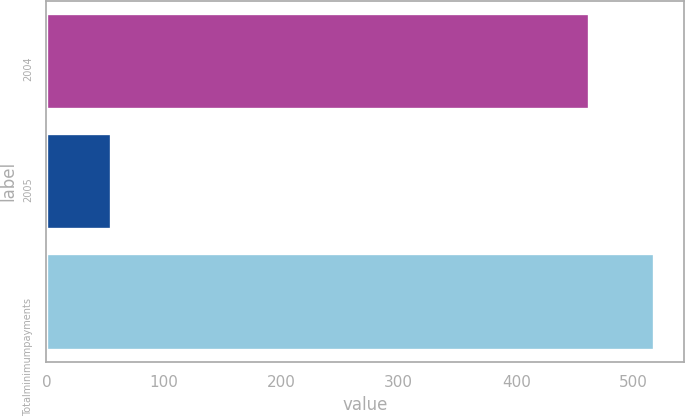Convert chart to OTSL. <chart><loc_0><loc_0><loc_500><loc_500><bar_chart><fcel>2004<fcel>2005<fcel>Totalminimumpayments<nl><fcel>462<fcel>55<fcel>517<nl></chart> 